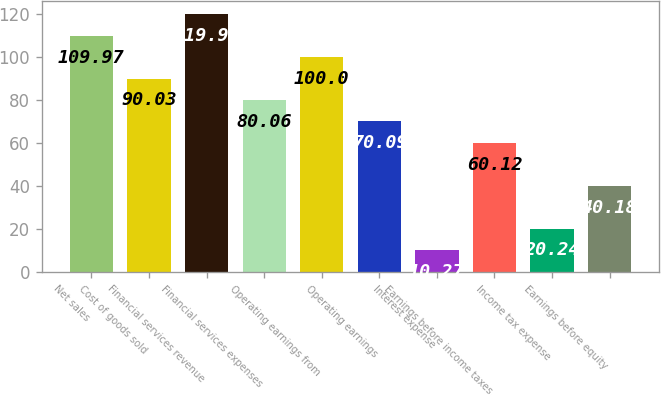Convert chart. <chart><loc_0><loc_0><loc_500><loc_500><bar_chart><fcel>Net sales<fcel>Cost of goods sold<fcel>Financial services revenue<fcel>Financial services expenses<fcel>Operating earnings from<fcel>Operating earnings<fcel>Interest expense<fcel>Earnings before income taxes<fcel>Income tax expense<fcel>Earnings before equity<nl><fcel>109.97<fcel>90.03<fcel>119.94<fcel>80.06<fcel>100<fcel>70.09<fcel>10.27<fcel>60.12<fcel>20.24<fcel>40.18<nl></chart> 